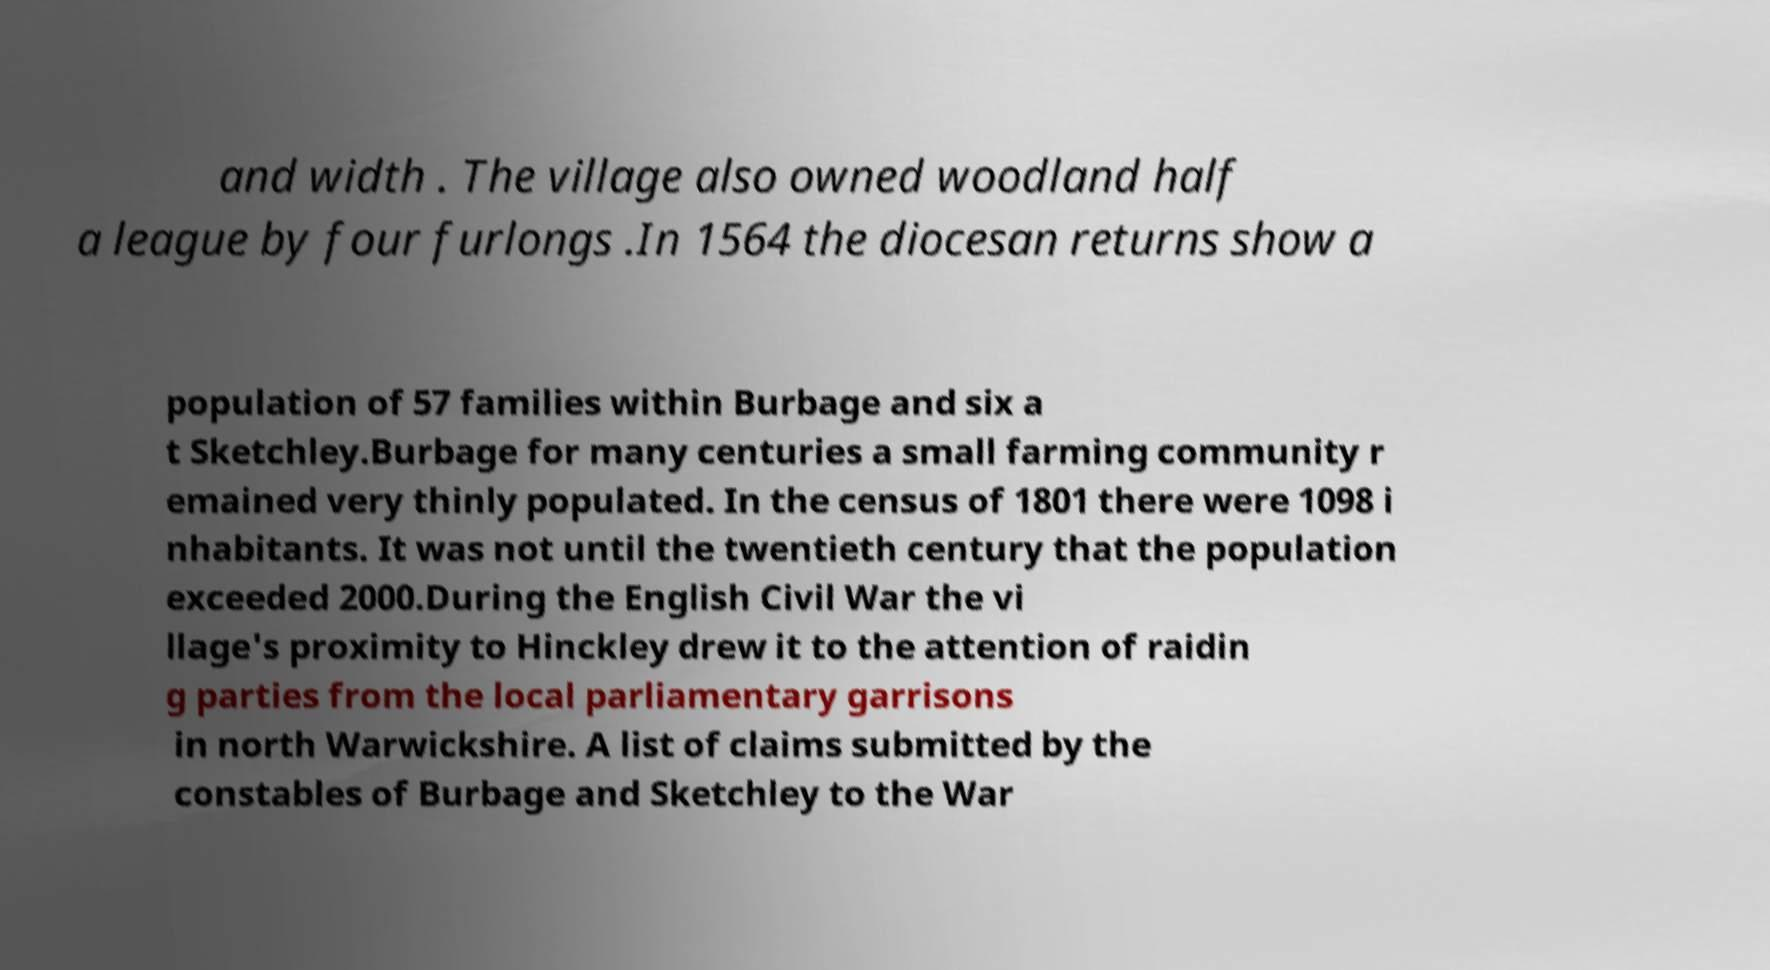Can you accurately transcribe the text from the provided image for me? and width . The village also owned woodland half a league by four furlongs .In 1564 the diocesan returns show a population of 57 families within Burbage and six a t Sketchley.Burbage for many centuries a small farming community r emained very thinly populated. In the census of 1801 there were 1098 i nhabitants. It was not until the twentieth century that the population exceeded 2000.During the English Civil War the vi llage's proximity to Hinckley drew it to the attention of raidin g parties from the local parliamentary garrisons in north Warwickshire. A list of claims submitted by the constables of Burbage and Sketchley to the War 